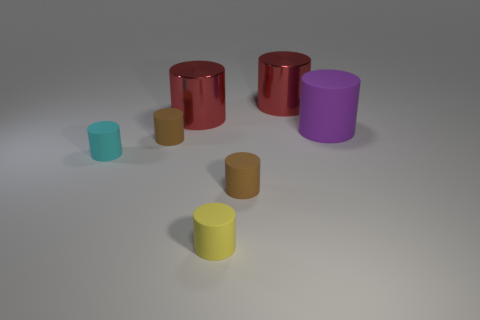Subtract all purple cylinders. How many cylinders are left? 6 Subtract all big metal cylinders. How many cylinders are left? 5 Add 3 large purple rubber things. How many objects exist? 10 Subtract all blue cylinders. Subtract all blue balls. How many cylinders are left? 7 Subtract all cyan blocks. How many cyan cylinders are left? 1 Subtract all large green cylinders. Subtract all purple cylinders. How many objects are left? 6 Add 6 large purple cylinders. How many large purple cylinders are left? 7 Add 6 purple things. How many purple things exist? 7 Subtract 0 brown spheres. How many objects are left? 7 